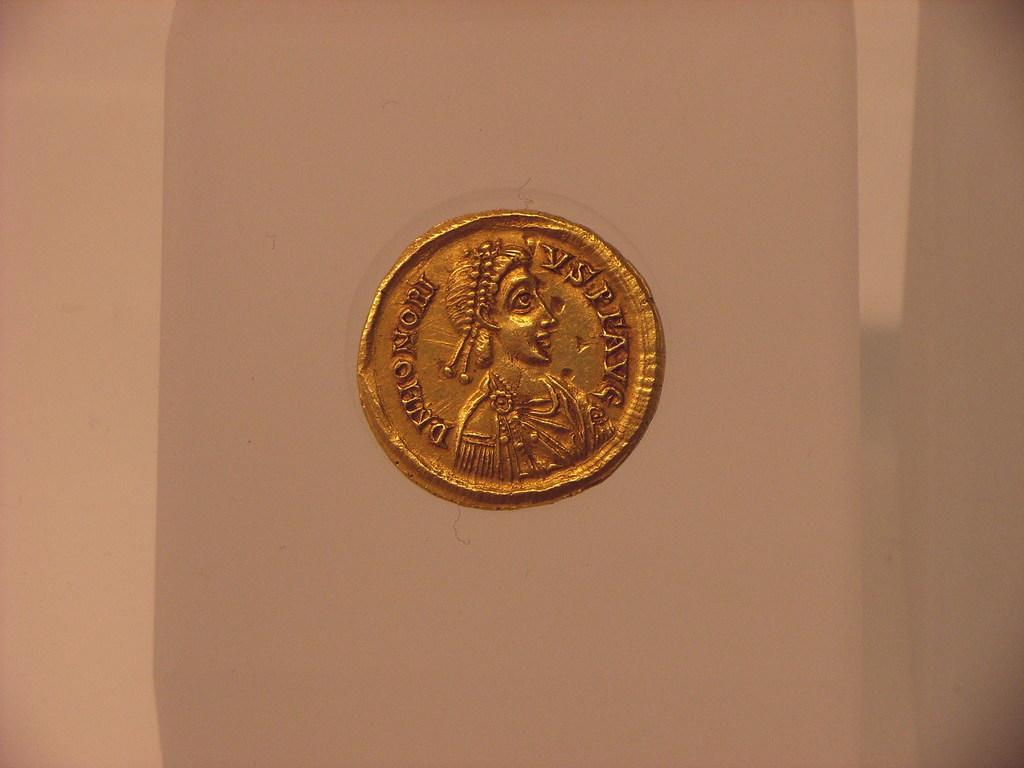What object is the main focus of the image? There is a coin in the image. What is depicted on the coin? The coin has a face on it. Are there any words or letters on the coin? Yes, there is text on the coin. Is there a fire burning near the coin in the image? No, there is no fire present in the image. What type of mailbox is shown next to the coin in the image? There is no mailbox present in the image; it only features a coin. 